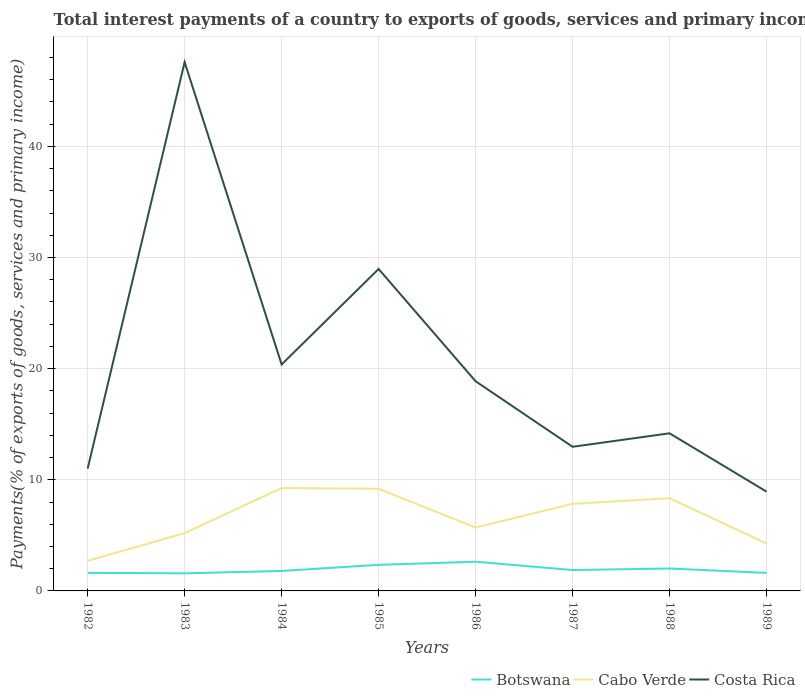How many different coloured lines are there?
Your answer should be compact. 3. Is the number of lines equal to the number of legend labels?
Your response must be concise. Yes. Across all years, what is the maximum total interest payments in Costa Rica?
Keep it short and to the point. 8.93. In which year was the total interest payments in Botswana maximum?
Offer a very short reply. 1983. What is the total total interest payments in Botswana in the graph?
Your answer should be compact. -0.04. What is the difference between the highest and the second highest total interest payments in Cabo Verde?
Offer a very short reply. 6.55. How many years are there in the graph?
Keep it short and to the point. 8. What is the difference between two consecutive major ticks on the Y-axis?
Make the answer very short. 10. Are the values on the major ticks of Y-axis written in scientific E-notation?
Provide a succinct answer. No. Where does the legend appear in the graph?
Offer a terse response. Bottom right. How many legend labels are there?
Give a very brief answer. 3. How are the legend labels stacked?
Offer a terse response. Horizontal. What is the title of the graph?
Your answer should be compact. Total interest payments of a country to exports of goods, services and primary income. Does "South Asia" appear as one of the legend labels in the graph?
Offer a terse response. No. What is the label or title of the X-axis?
Make the answer very short. Years. What is the label or title of the Y-axis?
Offer a terse response. Payments(% of exports of goods, services and primary income). What is the Payments(% of exports of goods, services and primary income) in Botswana in 1982?
Your response must be concise. 1.63. What is the Payments(% of exports of goods, services and primary income) of Cabo Verde in 1982?
Make the answer very short. 2.7. What is the Payments(% of exports of goods, services and primary income) in Costa Rica in 1982?
Ensure brevity in your answer.  11.01. What is the Payments(% of exports of goods, services and primary income) of Botswana in 1983?
Ensure brevity in your answer.  1.58. What is the Payments(% of exports of goods, services and primary income) of Cabo Verde in 1983?
Provide a short and direct response. 5.2. What is the Payments(% of exports of goods, services and primary income) of Costa Rica in 1983?
Your answer should be very brief. 47.58. What is the Payments(% of exports of goods, services and primary income) in Botswana in 1984?
Ensure brevity in your answer.  1.8. What is the Payments(% of exports of goods, services and primary income) of Cabo Verde in 1984?
Your answer should be compact. 9.26. What is the Payments(% of exports of goods, services and primary income) in Costa Rica in 1984?
Give a very brief answer. 20.37. What is the Payments(% of exports of goods, services and primary income) in Botswana in 1985?
Your answer should be compact. 2.35. What is the Payments(% of exports of goods, services and primary income) of Cabo Verde in 1985?
Keep it short and to the point. 9.19. What is the Payments(% of exports of goods, services and primary income) in Costa Rica in 1985?
Provide a short and direct response. 28.97. What is the Payments(% of exports of goods, services and primary income) in Botswana in 1986?
Offer a terse response. 2.63. What is the Payments(% of exports of goods, services and primary income) of Cabo Verde in 1986?
Make the answer very short. 5.7. What is the Payments(% of exports of goods, services and primary income) of Costa Rica in 1986?
Provide a succinct answer. 18.86. What is the Payments(% of exports of goods, services and primary income) of Botswana in 1987?
Give a very brief answer. 1.88. What is the Payments(% of exports of goods, services and primary income) of Cabo Verde in 1987?
Offer a terse response. 7.84. What is the Payments(% of exports of goods, services and primary income) of Costa Rica in 1987?
Provide a short and direct response. 12.97. What is the Payments(% of exports of goods, services and primary income) of Botswana in 1988?
Make the answer very short. 2.02. What is the Payments(% of exports of goods, services and primary income) of Cabo Verde in 1988?
Your answer should be very brief. 8.34. What is the Payments(% of exports of goods, services and primary income) of Costa Rica in 1988?
Offer a terse response. 14.18. What is the Payments(% of exports of goods, services and primary income) of Botswana in 1989?
Offer a terse response. 1.62. What is the Payments(% of exports of goods, services and primary income) in Cabo Verde in 1989?
Provide a succinct answer. 4.27. What is the Payments(% of exports of goods, services and primary income) in Costa Rica in 1989?
Ensure brevity in your answer.  8.93. Across all years, what is the maximum Payments(% of exports of goods, services and primary income) in Botswana?
Provide a succinct answer. 2.63. Across all years, what is the maximum Payments(% of exports of goods, services and primary income) of Cabo Verde?
Ensure brevity in your answer.  9.26. Across all years, what is the maximum Payments(% of exports of goods, services and primary income) of Costa Rica?
Offer a terse response. 47.58. Across all years, what is the minimum Payments(% of exports of goods, services and primary income) of Botswana?
Ensure brevity in your answer.  1.58. Across all years, what is the minimum Payments(% of exports of goods, services and primary income) of Cabo Verde?
Your answer should be compact. 2.7. Across all years, what is the minimum Payments(% of exports of goods, services and primary income) in Costa Rica?
Your answer should be compact. 8.93. What is the total Payments(% of exports of goods, services and primary income) of Botswana in the graph?
Give a very brief answer. 15.5. What is the total Payments(% of exports of goods, services and primary income) in Cabo Verde in the graph?
Offer a terse response. 52.5. What is the total Payments(% of exports of goods, services and primary income) in Costa Rica in the graph?
Offer a terse response. 162.87. What is the difference between the Payments(% of exports of goods, services and primary income) in Botswana in 1982 and that in 1983?
Ensure brevity in your answer.  0.05. What is the difference between the Payments(% of exports of goods, services and primary income) of Cabo Verde in 1982 and that in 1983?
Offer a terse response. -2.49. What is the difference between the Payments(% of exports of goods, services and primary income) in Costa Rica in 1982 and that in 1983?
Offer a terse response. -36.57. What is the difference between the Payments(% of exports of goods, services and primary income) in Botswana in 1982 and that in 1984?
Keep it short and to the point. -0.17. What is the difference between the Payments(% of exports of goods, services and primary income) of Cabo Verde in 1982 and that in 1984?
Offer a very short reply. -6.55. What is the difference between the Payments(% of exports of goods, services and primary income) in Costa Rica in 1982 and that in 1984?
Provide a short and direct response. -9.37. What is the difference between the Payments(% of exports of goods, services and primary income) of Botswana in 1982 and that in 1985?
Give a very brief answer. -0.72. What is the difference between the Payments(% of exports of goods, services and primary income) of Cabo Verde in 1982 and that in 1985?
Provide a short and direct response. -6.49. What is the difference between the Payments(% of exports of goods, services and primary income) of Costa Rica in 1982 and that in 1985?
Offer a terse response. -17.96. What is the difference between the Payments(% of exports of goods, services and primary income) in Botswana in 1982 and that in 1986?
Your answer should be very brief. -1. What is the difference between the Payments(% of exports of goods, services and primary income) of Cabo Verde in 1982 and that in 1986?
Provide a short and direct response. -3. What is the difference between the Payments(% of exports of goods, services and primary income) in Costa Rica in 1982 and that in 1986?
Ensure brevity in your answer.  -7.86. What is the difference between the Payments(% of exports of goods, services and primary income) in Botswana in 1982 and that in 1987?
Give a very brief answer. -0.25. What is the difference between the Payments(% of exports of goods, services and primary income) of Cabo Verde in 1982 and that in 1987?
Keep it short and to the point. -5.13. What is the difference between the Payments(% of exports of goods, services and primary income) in Costa Rica in 1982 and that in 1987?
Offer a very short reply. -1.96. What is the difference between the Payments(% of exports of goods, services and primary income) of Botswana in 1982 and that in 1988?
Your response must be concise. -0.39. What is the difference between the Payments(% of exports of goods, services and primary income) of Cabo Verde in 1982 and that in 1988?
Your answer should be very brief. -5.63. What is the difference between the Payments(% of exports of goods, services and primary income) in Costa Rica in 1982 and that in 1988?
Give a very brief answer. -3.18. What is the difference between the Payments(% of exports of goods, services and primary income) in Botswana in 1982 and that in 1989?
Your answer should be very brief. 0.01. What is the difference between the Payments(% of exports of goods, services and primary income) in Cabo Verde in 1982 and that in 1989?
Offer a terse response. -1.56. What is the difference between the Payments(% of exports of goods, services and primary income) in Costa Rica in 1982 and that in 1989?
Provide a short and direct response. 2.07. What is the difference between the Payments(% of exports of goods, services and primary income) of Botswana in 1983 and that in 1984?
Ensure brevity in your answer.  -0.21. What is the difference between the Payments(% of exports of goods, services and primary income) in Cabo Verde in 1983 and that in 1984?
Provide a succinct answer. -4.06. What is the difference between the Payments(% of exports of goods, services and primary income) in Costa Rica in 1983 and that in 1984?
Provide a succinct answer. 27.2. What is the difference between the Payments(% of exports of goods, services and primary income) in Botswana in 1983 and that in 1985?
Your response must be concise. -0.77. What is the difference between the Payments(% of exports of goods, services and primary income) of Cabo Verde in 1983 and that in 1985?
Keep it short and to the point. -3.99. What is the difference between the Payments(% of exports of goods, services and primary income) of Costa Rica in 1983 and that in 1985?
Offer a very short reply. 18.61. What is the difference between the Payments(% of exports of goods, services and primary income) in Botswana in 1983 and that in 1986?
Offer a very short reply. -1.04. What is the difference between the Payments(% of exports of goods, services and primary income) in Cabo Verde in 1983 and that in 1986?
Your response must be concise. -0.5. What is the difference between the Payments(% of exports of goods, services and primary income) in Costa Rica in 1983 and that in 1986?
Make the answer very short. 28.71. What is the difference between the Payments(% of exports of goods, services and primary income) of Botswana in 1983 and that in 1987?
Keep it short and to the point. -0.3. What is the difference between the Payments(% of exports of goods, services and primary income) of Cabo Verde in 1983 and that in 1987?
Provide a short and direct response. -2.64. What is the difference between the Payments(% of exports of goods, services and primary income) in Costa Rica in 1983 and that in 1987?
Offer a terse response. 34.61. What is the difference between the Payments(% of exports of goods, services and primary income) in Botswana in 1983 and that in 1988?
Provide a succinct answer. -0.44. What is the difference between the Payments(% of exports of goods, services and primary income) of Cabo Verde in 1983 and that in 1988?
Your answer should be compact. -3.14. What is the difference between the Payments(% of exports of goods, services and primary income) in Costa Rica in 1983 and that in 1988?
Provide a short and direct response. 33.4. What is the difference between the Payments(% of exports of goods, services and primary income) of Botswana in 1983 and that in 1989?
Ensure brevity in your answer.  -0.04. What is the difference between the Payments(% of exports of goods, services and primary income) of Cabo Verde in 1983 and that in 1989?
Ensure brevity in your answer.  0.93. What is the difference between the Payments(% of exports of goods, services and primary income) in Costa Rica in 1983 and that in 1989?
Your answer should be compact. 38.65. What is the difference between the Payments(% of exports of goods, services and primary income) of Botswana in 1984 and that in 1985?
Give a very brief answer. -0.55. What is the difference between the Payments(% of exports of goods, services and primary income) of Cabo Verde in 1984 and that in 1985?
Make the answer very short. 0.06. What is the difference between the Payments(% of exports of goods, services and primary income) in Costa Rica in 1984 and that in 1985?
Your response must be concise. -8.59. What is the difference between the Payments(% of exports of goods, services and primary income) of Botswana in 1984 and that in 1986?
Your response must be concise. -0.83. What is the difference between the Payments(% of exports of goods, services and primary income) of Cabo Verde in 1984 and that in 1986?
Keep it short and to the point. 3.55. What is the difference between the Payments(% of exports of goods, services and primary income) in Costa Rica in 1984 and that in 1986?
Ensure brevity in your answer.  1.51. What is the difference between the Payments(% of exports of goods, services and primary income) in Botswana in 1984 and that in 1987?
Make the answer very short. -0.08. What is the difference between the Payments(% of exports of goods, services and primary income) of Cabo Verde in 1984 and that in 1987?
Offer a very short reply. 1.42. What is the difference between the Payments(% of exports of goods, services and primary income) of Costa Rica in 1984 and that in 1987?
Offer a very short reply. 7.41. What is the difference between the Payments(% of exports of goods, services and primary income) in Botswana in 1984 and that in 1988?
Offer a very short reply. -0.22. What is the difference between the Payments(% of exports of goods, services and primary income) in Cabo Verde in 1984 and that in 1988?
Keep it short and to the point. 0.92. What is the difference between the Payments(% of exports of goods, services and primary income) of Costa Rica in 1984 and that in 1988?
Your response must be concise. 6.19. What is the difference between the Payments(% of exports of goods, services and primary income) in Botswana in 1984 and that in 1989?
Provide a short and direct response. 0.17. What is the difference between the Payments(% of exports of goods, services and primary income) in Cabo Verde in 1984 and that in 1989?
Provide a short and direct response. 4.99. What is the difference between the Payments(% of exports of goods, services and primary income) in Costa Rica in 1984 and that in 1989?
Ensure brevity in your answer.  11.44. What is the difference between the Payments(% of exports of goods, services and primary income) of Botswana in 1985 and that in 1986?
Provide a succinct answer. -0.28. What is the difference between the Payments(% of exports of goods, services and primary income) in Cabo Verde in 1985 and that in 1986?
Provide a short and direct response. 3.49. What is the difference between the Payments(% of exports of goods, services and primary income) in Costa Rica in 1985 and that in 1986?
Keep it short and to the point. 10.1. What is the difference between the Payments(% of exports of goods, services and primary income) of Botswana in 1985 and that in 1987?
Provide a short and direct response. 0.47. What is the difference between the Payments(% of exports of goods, services and primary income) in Cabo Verde in 1985 and that in 1987?
Ensure brevity in your answer.  1.35. What is the difference between the Payments(% of exports of goods, services and primary income) of Costa Rica in 1985 and that in 1987?
Your answer should be very brief. 16. What is the difference between the Payments(% of exports of goods, services and primary income) of Botswana in 1985 and that in 1988?
Provide a short and direct response. 0.33. What is the difference between the Payments(% of exports of goods, services and primary income) in Cabo Verde in 1985 and that in 1988?
Provide a short and direct response. 0.85. What is the difference between the Payments(% of exports of goods, services and primary income) in Costa Rica in 1985 and that in 1988?
Your answer should be compact. 14.78. What is the difference between the Payments(% of exports of goods, services and primary income) of Botswana in 1985 and that in 1989?
Provide a succinct answer. 0.72. What is the difference between the Payments(% of exports of goods, services and primary income) of Cabo Verde in 1985 and that in 1989?
Keep it short and to the point. 4.92. What is the difference between the Payments(% of exports of goods, services and primary income) of Costa Rica in 1985 and that in 1989?
Your answer should be very brief. 20.03. What is the difference between the Payments(% of exports of goods, services and primary income) of Botswana in 1986 and that in 1987?
Offer a very short reply. 0.75. What is the difference between the Payments(% of exports of goods, services and primary income) of Cabo Verde in 1986 and that in 1987?
Your answer should be compact. -2.14. What is the difference between the Payments(% of exports of goods, services and primary income) of Costa Rica in 1986 and that in 1987?
Offer a terse response. 5.9. What is the difference between the Payments(% of exports of goods, services and primary income) of Botswana in 1986 and that in 1988?
Provide a short and direct response. 0.61. What is the difference between the Payments(% of exports of goods, services and primary income) of Cabo Verde in 1986 and that in 1988?
Keep it short and to the point. -2.64. What is the difference between the Payments(% of exports of goods, services and primary income) in Costa Rica in 1986 and that in 1988?
Provide a short and direct response. 4.68. What is the difference between the Payments(% of exports of goods, services and primary income) in Botswana in 1986 and that in 1989?
Make the answer very short. 1. What is the difference between the Payments(% of exports of goods, services and primary income) of Cabo Verde in 1986 and that in 1989?
Ensure brevity in your answer.  1.44. What is the difference between the Payments(% of exports of goods, services and primary income) in Costa Rica in 1986 and that in 1989?
Your response must be concise. 9.93. What is the difference between the Payments(% of exports of goods, services and primary income) in Botswana in 1987 and that in 1988?
Make the answer very short. -0.14. What is the difference between the Payments(% of exports of goods, services and primary income) in Cabo Verde in 1987 and that in 1988?
Make the answer very short. -0.5. What is the difference between the Payments(% of exports of goods, services and primary income) in Costa Rica in 1987 and that in 1988?
Offer a very short reply. -1.21. What is the difference between the Payments(% of exports of goods, services and primary income) of Botswana in 1987 and that in 1989?
Keep it short and to the point. 0.26. What is the difference between the Payments(% of exports of goods, services and primary income) of Cabo Verde in 1987 and that in 1989?
Your answer should be very brief. 3.57. What is the difference between the Payments(% of exports of goods, services and primary income) of Costa Rica in 1987 and that in 1989?
Your response must be concise. 4.04. What is the difference between the Payments(% of exports of goods, services and primary income) in Botswana in 1988 and that in 1989?
Provide a short and direct response. 0.4. What is the difference between the Payments(% of exports of goods, services and primary income) of Cabo Verde in 1988 and that in 1989?
Provide a short and direct response. 4.07. What is the difference between the Payments(% of exports of goods, services and primary income) in Costa Rica in 1988 and that in 1989?
Give a very brief answer. 5.25. What is the difference between the Payments(% of exports of goods, services and primary income) of Botswana in 1982 and the Payments(% of exports of goods, services and primary income) of Cabo Verde in 1983?
Give a very brief answer. -3.57. What is the difference between the Payments(% of exports of goods, services and primary income) in Botswana in 1982 and the Payments(% of exports of goods, services and primary income) in Costa Rica in 1983?
Offer a very short reply. -45.95. What is the difference between the Payments(% of exports of goods, services and primary income) in Cabo Verde in 1982 and the Payments(% of exports of goods, services and primary income) in Costa Rica in 1983?
Give a very brief answer. -44.87. What is the difference between the Payments(% of exports of goods, services and primary income) of Botswana in 1982 and the Payments(% of exports of goods, services and primary income) of Cabo Verde in 1984?
Your response must be concise. -7.63. What is the difference between the Payments(% of exports of goods, services and primary income) of Botswana in 1982 and the Payments(% of exports of goods, services and primary income) of Costa Rica in 1984?
Keep it short and to the point. -18.75. What is the difference between the Payments(% of exports of goods, services and primary income) in Cabo Verde in 1982 and the Payments(% of exports of goods, services and primary income) in Costa Rica in 1984?
Provide a succinct answer. -17.67. What is the difference between the Payments(% of exports of goods, services and primary income) in Botswana in 1982 and the Payments(% of exports of goods, services and primary income) in Cabo Verde in 1985?
Give a very brief answer. -7.56. What is the difference between the Payments(% of exports of goods, services and primary income) in Botswana in 1982 and the Payments(% of exports of goods, services and primary income) in Costa Rica in 1985?
Provide a succinct answer. -27.34. What is the difference between the Payments(% of exports of goods, services and primary income) in Cabo Verde in 1982 and the Payments(% of exports of goods, services and primary income) in Costa Rica in 1985?
Your answer should be very brief. -26.26. What is the difference between the Payments(% of exports of goods, services and primary income) of Botswana in 1982 and the Payments(% of exports of goods, services and primary income) of Cabo Verde in 1986?
Offer a terse response. -4.07. What is the difference between the Payments(% of exports of goods, services and primary income) in Botswana in 1982 and the Payments(% of exports of goods, services and primary income) in Costa Rica in 1986?
Keep it short and to the point. -17.24. What is the difference between the Payments(% of exports of goods, services and primary income) in Cabo Verde in 1982 and the Payments(% of exports of goods, services and primary income) in Costa Rica in 1986?
Your response must be concise. -16.16. What is the difference between the Payments(% of exports of goods, services and primary income) of Botswana in 1982 and the Payments(% of exports of goods, services and primary income) of Cabo Verde in 1987?
Your answer should be very brief. -6.21. What is the difference between the Payments(% of exports of goods, services and primary income) in Botswana in 1982 and the Payments(% of exports of goods, services and primary income) in Costa Rica in 1987?
Give a very brief answer. -11.34. What is the difference between the Payments(% of exports of goods, services and primary income) in Cabo Verde in 1982 and the Payments(% of exports of goods, services and primary income) in Costa Rica in 1987?
Your response must be concise. -10.26. What is the difference between the Payments(% of exports of goods, services and primary income) of Botswana in 1982 and the Payments(% of exports of goods, services and primary income) of Cabo Verde in 1988?
Provide a short and direct response. -6.71. What is the difference between the Payments(% of exports of goods, services and primary income) of Botswana in 1982 and the Payments(% of exports of goods, services and primary income) of Costa Rica in 1988?
Your answer should be compact. -12.55. What is the difference between the Payments(% of exports of goods, services and primary income) of Cabo Verde in 1982 and the Payments(% of exports of goods, services and primary income) of Costa Rica in 1988?
Provide a short and direct response. -11.48. What is the difference between the Payments(% of exports of goods, services and primary income) in Botswana in 1982 and the Payments(% of exports of goods, services and primary income) in Cabo Verde in 1989?
Ensure brevity in your answer.  -2.64. What is the difference between the Payments(% of exports of goods, services and primary income) of Botswana in 1982 and the Payments(% of exports of goods, services and primary income) of Costa Rica in 1989?
Offer a very short reply. -7.3. What is the difference between the Payments(% of exports of goods, services and primary income) in Cabo Verde in 1982 and the Payments(% of exports of goods, services and primary income) in Costa Rica in 1989?
Offer a very short reply. -6.23. What is the difference between the Payments(% of exports of goods, services and primary income) of Botswana in 1983 and the Payments(% of exports of goods, services and primary income) of Cabo Verde in 1984?
Provide a short and direct response. -7.67. What is the difference between the Payments(% of exports of goods, services and primary income) of Botswana in 1983 and the Payments(% of exports of goods, services and primary income) of Costa Rica in 1984?
Provide a short and direct response. -18.79. What is the difference between the Payments(% of exports of goods, services and primary income) in Cabo Verde in 1983 and the Payments(% of exports of goods, services and primary income) in Costa Rica in 1984?
Your answer should be compact. -15.17. What is the difference between the Payments(% of exports of goods, services and primary income) in Botswana in 1983 and the Payments(% of exports of goods, services and primary income) in Cabo Verde in 1985?
Keep it short and to the point. -7.61. What is the difference between the Payments(% of exports of goods, services and primary income) in Botswana in 1983 and the Payments(% of exports of goods, services and primary income) in Costa Rica in 1985?
Give a very brief answer. -27.38. What is the difference between the Payments(% of exports of goods, services and primary income) of Cabo Verde in 1983 and the Payments(% of exports of goods, services and primary income) of Costa Rica in 1985?
Ensure brevity in your answer.  -23.77. What is the difference between the Payments(% of exports of goods, services and primary income) of Botswana in 1983 and the Payments(% of exports of goods, services and primary income) of Cabo Verde in 1986?
Your response must be concise. -4.12. What is the difference between the Payments(% of exports of goods, services and primary income) in Botswana in 1983 and the Payments(% of exports of goods, services and primary income) in Costa Rica in 1986?
Offer a very short reply. -17.28. What is the difference between the Payments(% of exports of goods, services and primary income) in Cabo Verde in 1983 and the Payments(% of exports of goods, services and primary income) in Costa Rica in 1986?
Your answer should be compact. -13.67. What is the difference between the Payments(% of exports of goods, services and primary income) in Botswana in 1983 and the Payments(% of exports of goods, services and primary income) in Cabo Verde in 1987?
Your response must be concise. -6.26. What is the difference between the Payments(% of exports of goods, services and primary income) of Botswana in 1983 and the Payments(% of exports of goods, services and primary income) of Costa Rica in 1987?
Offer a terse response. -11.39. What is the difference between the Payments(% of exports of goods, services and primary income) of Cabo Verde in 1983 and the Payments(% of exports of goods, services and primary income) of Costa Rica in 1987?
Your response must be concise. -7.77. What is the difference between the Payments(% of exports of goods, services and primary income) of Botswana in 1983 and the Payments(% of exports of goods, services and primary income) of Cabo Verde in 1988?
Offer a very short reply. -6.76. What is the difference between the Payments(% of exports of goods, services and primary income) in Botswana in 1983 and the Payments(% of exports of goods, services and primary income) in Costa Rica in 1988?
Make the answer very short. -12.6. What is the difference between the Payments(% of exports of goods, services and primary income) of Cabo Verde in 1983 and the Payments(% of exports of goods, services and primary income) of Costa Rica in 1988?
Provide a short and direct response. -8.98. What is the difference between the Payments(% of exports of goods, services and primary income) of Botswana in 1983 and the Payments(% of exports of goods, services and primary income) of Cabo Verde in 1989?
Offer a terse response. -2.69. What is the difference between the Payments(% of exports of goods, services and primary income) in Botswana in 1983 and the Payments(% of exports of goods, services and primary income) in Costa Rica in 1989?
Your answer should be compact. -7.35. What is the difference between the Payments(% of exports of goods, services and primary income) of Cabo Verde in 1983 and the Payments(% of exports of goods, services and primary income) of Costa Rica in 1989?
Make the answer very short. -3.73. What is the difference between the Payments(% of exports of goods, services and primary income) of Botswana in 1984 and the Payments(% of exports of goods, services and primary income) of Cabo Verde in 1985?
Make the answer very short. -7.39. What is the difference between the Payments(% of exports of goods, services and primary income) in Botswana in 1984 and the Payments(% of exports of goods, services and primary income) in Costa Rica in 1985?
Keep it short and to the point. -27.17. What is the difference between the Payments(% of exports of goods, services and primary income) in Cabo Verde in 1984 and the Payments(% of exports of goods, services and primary income) in Costa Rica in 1985?
Ensure brevity in your answer.  -19.71. What is the difference between the Payments(% of exports of goods, services and primary income) of Botswana in 1984 and the Payments(% of exports of goods, services and primary income) of Cabo Verde in 1986?
Give a very brief answer. -3.91. What is the difference between the Payments(% of exports of goods, services and primary income) in Botswana in 1984 and the Payments(% of exports of goods, services and primary income) in Costa Rica in 1986?
Provide a succinct answer. -17.07. What is the difference between the Payments(% of exports of goods, services and primary income) in Cabo Verde in 1984 and the Payments(% of exports of goods, services and primary income) in Costa Rica in 1986?
Your answer should be very brief. -9.61. What is the difference between the Payments(% of exports of goods, services and primary income) in Botswana in 1984 and the Payments(% of exports of goods, services and primary income) in Cabo Verde in 1987?
Provide a short and direct response. -6.04. What is the difference between the Payments(% of exports of goods, services and primary income) of Botswana in 1984 and the Payments(% of exports of goods, services and primary income) of Costa Rica in 1987?
Ensure brevity in your answer.  -11.17. What is the difference between the Payments(% of exports of goods, services and primary income) of Cabo Verde in 1984 and the Payments(% of exports of goods, services and primary income) of Costa Rica in 1987?
Give a very brief answer. -3.71. What is the difference between the Payments(% of exports of goods, services and primary income) in Botswana in 1984 and the Payments(% of exports of goods, services and primary income) in Cabo Verde in 1988?
Give a very brief answer. -6.54. What is the difference between the Payments(% of exports of goods, services and primary income) in Botswana in 1984 and the Payments(% of exports of goods, services and primary income) in Costa Rica in 1988?
Your response must be concise. -12.38. What is the difference between the Payments(% of exports of goods, services and primary income) of Cabo Verde in 1984 and the Payments(% of exports of goods, services and primary income) of Costa Rica in 1988?
Ensure brevity in your answer.  -4.93. What is the difference between the Payments(% of exports of goods, services and primary income) of Botswana in 1984 and the Payments(% of exports of goods, services and primary income) of Cabo Verde in 1989?
Keep it short and to the point. -2.47. What is the difference between the Payments(% of exports of goods, services and primary income) of Botswana in 1984 and the Payments(% of exports of goods, services and primary income) of Costa Rica in 1989?
Provide a short and direct response. -7.13. What is the difference between the Payments(% of exports of goods, services and primary income) in Cabo Verde in 1984 and the Payments(% of exports of goods, services and primary income) in Costa Rica in 1989?
Your answer should be compact. 0.32. What is the difference between the Payments(% of exports of goods, services and primary income) of Botswana in 1985 and the Payments(% of exports of goods, services and primary income) of Cabo Verde in 1986?
Provide a succinct answer. -3.36. What is the difference between the Payments(% of exports of goods, services and primary income) in Botswana in 1985 and the Payments(% of exports of goods, services and primary income) in Costa Rica in 1986?
Keep it short and to the point. -16.52. What is the difference between the Payments(% of exports of goods, services and primary income) in Cabo Verde in 1985 and the Payments(% of exports of goods, services and primary income) in Costa Rica in 1986?
Your answer should be compact. -9.67. What is the difference between the Payments(% of exports of goods, services and primary income) in Botswana in 1985 and the Payments(% of exports of goods, services and primary income) in Cabo Verde in 1987?
Provide a succinct answer. -5.49. What is the difference between the Payments(% of exports of goods, services and primary income) in Botswana in 1985 and the Payments(% of exports of goods, services and primary income) in Costa Rica in 1987?
Give a very brief answer. -10.62. What is the difference between the Payments(% of exports of goods, services and primary income) of Cabo Verde in 1985 and the Payments(% of exports of goods, services and primary income) of Costa Rica in 1987?
Offer a very short reply. -3.78. What is the difference between the Payments(% of exports of goods, services and primary income) of Botswana in 1985 and the Payments(% of exports of goods, services and primary income) of Cabo Verde in 1988?
Offer a terse response. -5.99. What is the difference between the Payments(% of exports of goods, services and primary income) in Botswana in 1985 and the Payments(% of exports of goods, services and primary income) in Costa Rica in 1988?
Ensure brevity in your answer.  -11.83. What is the difference between the Payments(% of exports of goods, services and primary income) of Cabo Verde in 1985 and the Payments(% of exports of goods, services and primary income) of Costa Rica in 1988?
Make the answer very short. -4.99. What is the difference between the Payments(% of exports of goods, services and primary income) of Botswana in 1985 and the Payments(% of exports of goods, services and primary income) of Cabo Verde in 1989?
Offer a terse response. -1.92. What is the difference between the Payments(% of exports of goods, services and primary income) in Botswana in 1985 and the Payments(% of exports of goods, services and primary income) in Costa Rica in 1989?
Your answer should be very brief. -6.58. What is the difference between the Payments(% of exports of goods, services and primary income) in Cabo Verde in 1985 and the Payments(% of exports of goods, services and primary income) in Costa Rica in 1989?
Your answer should be compact. 0.26. What is the difference between the Payments(% of exports of goods, services and primary income) of Botswana in 1986 and the Payments(% of exports of goods, services and primary income) of Cabo Verde in 1987?
Make the answer very short. -5.21. What is the difference between the Payments(% of exports of goods, services and primary income) of Botswana in 1986 and the Payments(% of exports of goods, services and primary income) of Costa Rica in 1987?
Your response must be concise. -10.34. What is the difference between the Payments(% of exports of goods, services and primary income) of Cabo Verde in 1986 and the Payments(% of exports of goods, services and primary income) of Costa Rica in 1987?
Offer a very short reply. -7.27. What is the difference between the Payments(% of exports of goods, services and primary income) of Botswana in 1986 and the Payments(% of exports of goods, services and primary income) of Cabo Verde in 1988?
Provide a succinct answer. -5.71. What is the difference between the Payments(% of exports of goods, services and primary income) in Botswana in 1986 and the Payments(% of exports of goods, services and primary income) in Costa Rica in 1988?
Provide a succinct answer. -11.56. What is the difference between the Payments(% of exports of goods, services and primary income) in Cabo Verde in 1986 and the Payments(% of exports of goods, services and primary income) in Costa Rica in 1988?
Provide a short and direct response. -8.48. What is the difference between the Payments(% of exports of goods, services and primary income) of Botswana in 1986 and the Payments(% of exports of goods, services and primary income) of Cabo Verde in 1989?
Provide a short and direct response. -1.64. What is the difference between the Payments(% of exports of goods, services and primary income) in Botswana in 1986 and the Payments(% of exports of goods, services and primary income) in Costa Rica in 1989?
Keep it short and to the point. -6.31. What is the difference between the Payments(% of exports of goods, services and primary income) of Cabo Verde in 1986 and the Payments(% of exports of goods, services and primary income) of Costa Rica in 1989?
Give a very brief answer. -3.23. What is the difference between the Payments(% of exports of goods, services and primary income) in Botswana in 1987 and the Payments(% of exports of goods, services and primary income) in Cabo Verde in 1988?
Make the answer very short. -6.46. What is the difference between the Payments(% of exports of goods, services and primary income) in Botswana in 1987 and the Payments(% of exports of goods, services and primary income) in Costa Rica in 1988?
Your answer should be compact. -12.3. What is the difference between the Payments(% of exports of goods, services and primary income) in Cabo Verde in 1987 and the Payments(% of exports of goods, services and primary income) in Costa Rica in 1988?
Your response must be concise. -6.34. What is the difference between the Payments(% of exports of goods, services and primary income) of Botswana in 1987 and the Payments(% of exports of goods, services and primary income) of Cabo Verde in 1989?
Keep it short and to the point. -2.39. What is the difference between the Payments(% of exports of goods, services and primary income) of Botswana in 1987 and the Payments(% of exports of goods, services and primary income) of Costa Rica in 1989?
Provide a short and direct response. -7.05. What is the difference between the Payments(% of exports of goods, services and primary income) of Cabo Verde in 1987 and the Payments(% of exports of goods, services and primary income) of Costa Rica in 1989?
Offer a terse response. -1.09. What is the difference between the Payments(% of exports of goods, services and primary income) in Botswana in 1988 and the Payments(% of exports of goods, services and primary income) in Cabo Verde in 1989?
Provide a short and direct response. -2.25. What is the difference between the Payments(% of exports of goods, services and primary income) in Botswana in 1988 and the Payments(% of exports of goods, services and primary income) in Costa Rica in 1989?
Make the answer very short. -6.91. What is the difference between the Payments(% of exports of goods, services and primary income) in Cabo Verde in 1988 and the Payments(% of exports of goods, services and primary income) in Costa Rica in 1989?
Give a very brief answer. -0.59. What is the average Payments(% of exports of goods, services and primary income) in Botswana per year?
Offer a very short reply. 1.94. What is the average Payments(% of exports of goods, services and primary income) in Cabo Verde per year?
Give a very brief answer. 6.56. What is the average Payments(% of exports of goods, services and primary income) of Costa Rica per year?
Make the answer very short. 20.36. In the year 1982, what is the difference between the Payments(% of exports of goods, services and primary income) in Botswana and Payments(% of exports of goods, services and primary income) in Cabo Verde?
Offer a terse response. -1.08. In the year 1982, what is the difference between the Payments(% of exports of goods, services and primary income) in Botswana and Payments(% of exports of goods, services and primary income) in Costa Rica?
Provide a succinct answer. -9.38. In the year 1982, what is the difference between the Payments(% of exports of goods, services and primary income) in Cabo Verde and Payments(% of exports of goods, services and primary income) in Costa Rica?
Your answer should be compact. -8.3. In the year 1983, what is the difference between the Payments(% of exports of goods, services and primary income) of Botswana and Payments(% of exports of goods, services and primary income) of Cabo Verde?
Give a very brief answer. -3.62. In the year 1983, what is the difference between the Payments(% of exports of goods, services and primary income) in Botswana and Payments(% of exports of goods, services and primary income) in Costa Rica?
Your answer should be very brief. -45.99. In the year 1983, what is the difference between the Payments(% of exports of goods, services and primary income) in Cabo Verde and Payments(% of exports of goods, services and primary income) in Costa Rica?
Make the answer very short. -42.38. In the year 1984, what is the difference between the Payments(% of exports of goods, services and primary income) of Botswana and Payments(% of exports of goods, services and primary income) of Cabo Verde?
Provide a short and direct response. -7.46. In the year 1984, what is the difference between the Payments(% of exports of goods, services and primary income) in Botswana and Payments(% of exports of goods, services and primary income) in Costa Rica?
Offer a terse response. -18.58. In the year 1984, what is the difference between the Payments(% of exports of goods, services and primary income) of Cabo Verde and Payments(% of exports of goods, services and primary income) of Costa Rica?
Keep it short and to the point. -11.12. In the year 1985, what is the difference between the Payments(% of exports of goods, services and primary income) in Botswana and Payments(% of exports of goods, services and primary income) in Cabo Verde?
Offer a very short reply. -6.84. In the year 1985, what is the difference between the Payments(% of exports of goods, services and primary income) of Botswana and Payments(% of exports of goods, services and primary income) of Costa Rica?
Keep it short and to the point. -26.62. In the year 1985, what is the difference between the Payments(% of exports of goods, services and primary income) of Cabo Verde and Payments(% of exports of goods, services and primary income) of Costa Rica?
Make the answer very short. -19.77. In the year 1986, what is the difference between the Payments(% of exports of goods, services and primary income) of Botswana and Payments(% of exports of goods, services and primary income) of Cabo Verde?
Ensure brevity in your answer.  -3.08. In the year 1986, what is the difference between the Payments(% of exports of goods, services and primary income) of Botswana and Payments(% of exports of goods, services and primary income) of Costa Rica?
Offer a very short reply. -16.24. In the year 1986, what is the difference between the Payments(% of exports of goods, services and primary income) of Cabo Verde and Payments(% of exports of goods, services and primary income) of Costa Rica?
Provide a short and direct response. -13.16. In the year 1987, what is the difference between the Payments(% of exports of goods, services and primary income) of Botswana and Payments(% of exports of goods, services and primary income) of Cabo Verde?
Give a very brief answer. -5.96. In the year 1987, what is the difference between the Payments(% of exports of goods, services and primary income) in Botswana and Payments(% of exports of goods, services and primary income) in Costa Rica?
Offer a terse response. -11.09. In the year 1987, what is the difference between the Payments(% of exports of goods, services and primary income) of Cabo Verde and Payments(% of exports of goods, services and primary income) of Costa Rica?
Your answer should be compact. -5.13. In the year 1988, what is the difference between the Payments(% of exports of goods, services and primary income) of Botswana and Payments(% of exports of goods, services and primary income) of Cabo Verde?
Make the answer very short. -6.32. In the year 1988, what is the difference between the Payments(% of exports of goods, services and primary income) of Botswana and Payments(% of exports of goods, services and primary income) of Costa Rica?
Your answer should be very brief. -12.16. In the year 1988, what is the difference between the Payments(% of exports of goods, services and primary income) in Cabo Verde and Payments(% of exports of goods, services and primary income) in Costa Rica?
Ensure brevity in your answer.  -5.84. In the year 1989, what is the difference between the Payments(% of exports of goods, services and primary income) in Botswana and Payments(% of exports of goods, services and primary income) in Cabo Verde?
Provide a succinct answer. -2.65. In the year 1989, what is the difference between the Payments(% of exports of goods, services and primary income) in Botswana and Payments(% of exports of goods, services and primary income) in Costa Rica?
Make the answer very short. -7.31. In the year 1989, what is the difference between the Payments(% of exports of goods, services and primary income) of Cabo Verde and Payments(% of exports of goods, services and primary income) of Costa Rica?
Your answer should be compact. -4.66. What is the ratio of the Payments(% of exports of goods, services and primary income) of Botswana in 1982 to that in 1983?
Make the answer very short. 1.03. What is the ratio of the Payments(% of exports of goods, services and primary income) in Cabo Verde in 1982 to that in 1983?
Your response must be concise. 0.52. What is the ratio of the Payments(% of exports of goods, services and primary income) in Costa Rica in 1982 to that in 1983?
Provide a short and direct response. 0.23. What is the ratio of the Payments(% of exports of goods, services and primary income) of Botswana in 1982 to that in 1984?
Your response must be concise. 0.91. What is the ratio of the Payments(% of exports of goods, services and primary income) of Cabo Verde in 1982 to that in 1984?
Provide a succinct answer. 0.29. What is the ratio of the Payments(% of exports of goods, services and primary income) in Costa Rica in 1982 to that in 1984?
Give a very brief answer. 0.54. What is the ratio of the Payments(% of exports of goods, services and primary income) of Botswana in 1982 to that in 1985?
Your response must be concise. 0.69. What is the ratio of the Payments(% of exports of goods, services and primary income) of Cabo Verde in 1982 to that in 1985?
Offer a very short reply. 0.29. What is the ratio of the Payments(% of exports of goods, services and primary income) in Costa Rica in 1982 to that in 1985?
Provide a short and direct response. 0.38. What is the ratio of the Payments(% of exports of goods, services and primary income) of Botswana in 1982 to that in 1986?
Your answer should be compact. 0.62. What is the ratio of the Payments(% of exports of goods, services and primary income) in Cabo Verde in 1982 to that in 1986?
Make the answer very short. 0.47. What is the ratio of the Payments(% of exports of goods, services and primary income) in Costa Rica in 1982 to that in 1986?
Offer a very short reply. 0.58. What is the ratio of the Payments(% of exports of goods, services and primary income) in Botswana in 1982 to that in 1987?
Your answer should be compact. 0.87. What is the ratio of the Payments(% of exports of goods, services and primary income) in Cabo Verde in 1982 to that in 1987?
Offer a terse response. 0.35. What is the ratio of the Payments(% of exports of goods, services and primary income) in Costa Rica in 1982 to that in 1987?
Keep it short and to the point. 0.85. What is the ratio of the Payments(% of exports of goods, services and primary income) in Botswana in 1982 to that in 1988?
Provide a short and direct response. 0.81. What is the ratio of the Payments(% of exports of goods, services and primary income) in Cabo Verde in 1982 to that in 1988?
Provide a short and direct response. 0.32. What is the ratio of the Payments(% of exports of goods, services and primary income) of Costa Rica in 1982 to that in 1988?
Provide a short and direct response. 0.78. What is the ratio of the Payments(% of exports of goods, services and primary income) in Botswana in 1982 to that in 1989?
Make the answer very short. 1. What is the ratio of the Payments(% of exports of goods, services and primary income) of Cabo Verde in 1982 to that in 1989?
Keep it short and to the point. 0.63. What is the ratio of the Payments(% of exports of goods, services and primary income) of Costa Rica in 1982 to that in 1989?
Your response must be concise. 1.23. What is the ratio of the Payments(% of exports of goods, services and primary income) in Botswana in 1983 to that in 1984?
Keep it short and to the point. 0.88. What is the ratio of the Payments(% of exports of goods, services and primary income) of Cabo Verde in 1983 to that in 1984?
Offer a very short reply. 0.56. What is the ratio of the Payments(% of exports of goods, services and primary income) of Costa Rica in 1983 to that in 1984?
Offer a very short reply. 2.34. What is the ratio of the Payments(% of exports of goods, services and primary income) in Botswana in 1983 to that in 1985?
Your answer should be compact. 0.67. What is the ratio of the Payments(% of exports of goods, services and primary income) of Cabo Verde in 1983 to that in 1985?
Your answer should be compact. 0.57. What is the ratio of the Payments(% of exports of goods, services and primary income) of Costa Rica in 1983 to that in 1985?
Your answer should be very brief. 1.64. What is the ratio of the Payments(% of exports of goods, services and primary income) of Botswana in 1983 to that in 1986?
Provide a succinct answer. 0.6. What is the ratio of the Payments(% of exports of goods, services and primary income) of Cabo Verde in 1983 to that in 1986?
Make the answer very short. 0.91. What is the ratio of the Payments(% of exports of goods, services and primary income) in Costa Rica in 1983 to that in 1986?
Your answer should be very brief. 2.52. What is the ratio of the Payments(% of exports of goods, services and primary income) of Botswana in 1983 to that in 1987?
Make the answer very short. 0.84. What is the ratio of the Payments(% of exports of goods, services and primary income) in Cabo Verde in 1983 to that in 1987?
Give a very brief answer. 0.66. What is the ratio of the Payments(% of exports of goods, services and primary income) of Costa Rica in 1983 to that in 1987?
Your answer should be compact. 3.67. What is the ratio of the Payments(% of exports of goods, services and primary income) of Botswana in 1983 to that in 1988?
Make the answer very short. 0.78. What is the ratio of the Payments(% of exports of goods, services and primary income) of Cabo Verde in 1983 to that in 1988?
Offer a very short reply. 0.62. What is the ratio of the Payments(% of exports of goods, services and primary income) in Costa Rica in 1983 to that in 1988?
Offer a terse response. 3.35. What is the ratio of the Payments(% of exports of goods, services and primary income) of Botswana in 1983 to that in 1989?
Make the answer very short. 0.98. What is the ratio of the Payments(% of exports of goods, services and primary income) in Cabo Verde in 1983 to that in 1989?
Your answer should be compact. 1.22. What is the ratio of the Payments(% of exports of goods, services and primary income) of Costa Rica in 1983 to that in 1989?
Offer a terse response. 5.33. What is the ratio of the Payments(% of exports of goods, services and primary income) of Botswana in 1984 to that in 1985?
Your response must be concise. 0.77. What is the ratio of the Payments(% of exports of goods, services and primary income) in Cabo Verde in 1984 to that in 1985?
Your answer should be compact. 1.01. What is the ratio of the Payments(% of exports of goods, services and primary income) in Costa Rica in 1984 to that in 1985?
Offer a terse response. 0.7. What is the ratio of the Payments(% of exports of goods, services and primary income) in Botswana in 1984 to that in 1986?
Give a very brief answer. 0.68. What is the ratio of the Payments(% of exports of goods, services and primary income) of Cabo Verde in 1984 to that in 1986?
Make the answer very short. 1.62. What is the ratio of the Payments(% of exports of goods, services and primary income) in Costa Rica in 1984 to that in 1986?
Your answer should be compact. 1.08. What is the ratio of the Payments(% of exports of goods, services and primary income) in Botswana in 1984 to that in 1987?
Make the answer very short. 0.96. What is the ratio of the Payments(% of exports of goods, services and primary income) of Cabo Verde in 1984 to that in 1987?
Your answer should be compact. 1.18. What is the ratio of the Payments(% of exports of goods, services and primary income) of Costa Rica in 1984 to that in 1987?
Keep it short and to the point. 1.57. What is the ratio of the Payments(% of exports of goods, services and primary income) of Botswana in 1984 to that in 1988?
Offer a very short reply. 0.89. What is the ratio of the Payments(% of exports of goods, services and primary income) of Cabo Verde in 1984 to that in 1988?
Make the answer very short. 1.11. What is the ratio of the Payments(% of exports of goods, services and primary income) of Costa Rica in 1984 to that in 1988?
Keep it short and to the point. 1.44. What is the ratio of the Payments(% of exports of goods, services and primary income) of Botswana in 1984 to that in 1989?
Keep it short and to the point. 1.11. What is the ratio of the Payments(% of exports of goods, services and primary income) in Cabo Verde in 1984 to that in 1989?
Your response must be concise. 2.17. What is the ratio of the Payments(% of exports of goods, services and primary income) of Costa Rica in 1984 to that in 1989?
Make the answer very short. 2.28. What is the ratio of the Payments(% of exports of goods, services and primary income) in Botswana in 1985 to that in 1986?
Provide a succinct answer. 0.89. What is the ratio of the Payments(% of exports of goods, services and primary income) of Cabo Verde in 1985 to that in 1986?
Give a very brief answer. 1.61. What is the ratio of the Payments(% of exports of goods, services and primary income) in Costa Rica in 1985 to that in 1986?
Make the answer very short. 1.54. What is the ratio of the Payments(% of exports of goods, services and primary income) of Botswana in 1985 to that in 1987?
Your response must be concise. 1.25. What is the ratio of the Payments(% of exports of goods, services and primary income) in Cabo Verde in 1985 to that in 1987?
Offer a terse response. 1.17. What is the ratio of the Payments(% of exports of goods, services and primary income) of Costa Rica in 1985 to that in 1987?
Offer a very short reply. 2.23. What is the ratio of the Payments(% of exports of goods, services and primary income) in Botswana in 1985 to that in 1988?
Provide a short and direct response. 1.16. What is the ratio of the Payments(% of exports of goods, services and primary income) in Cabo Verde in 1985 to that in 1988?
Your answer should be compact. 1.1. What is the ratio of the Payments(% of exports of goods, services and primary income) in Costa Rica in 1985 to that in 1988?
Provide a short and direct response. 2.04. What is the ratio of the Payments(% of exports of goods, services and primary income) of Botswana in 1985 to that in 1989?
Offer a terse response. 1.45. What is the ratio of the Payments(% of exports of goods, services and primary income) of Cabo Verde in 1985 to that in 1989?
Your answer should be compact. 2.15. What is the ratio of the Payments(% of exports of goods, services and primary income) in Costa Rica in 1985 to that in 1989?
Give a very brief answer. 3.24. What is the ratio of the Payments(% of exports of goods, services and primary income) of Botswana in 1986 to that in 1987?
Provide a short and direct response. 1.4. What is the ratio of the Payments(% of exports of goods, services and primary income) in Cabo Verde in 1986 to that in 1987?
Give a very brief answer. 0.73. What is the ratio of the Payments(% of exports of goods, services and primary income) of Costa Rica in 1986 to that in 1987?
Keep it short and to the point. 1.45. What is the ratio of the Payments(% of exports of goods, services and primary income) in Botswana in 1986 to that in 1988?
Keep it short and to the point. 1.3. What is the ratio of the Payments(% of exports of goods, services and primary income) in Cabo Verde in 1986 to that in 1988?
Keep it short and to the point. 0.68. What is the ratio of the Payments(% of exports of goods, services and primary income) in Costa Rica in 1986 to that in 1988?
Provide a short and direct response. 1.33. What is the ratio of the Payments(% of exports of goods, services and primary income) of Botswana in 1986 to that in 1989?
Offer a very short reply. 1.62. What is the ratio of the Payments(% of exports of goods, services and primary income) in Cabo Verde in 1986 to that in 1989?
Provide a succinct answer. 1.34. What is the ratio of the Payments(% of exports of goods, services and primary income) of Costa Rica in 1986 to that in 1989?
Your answer should be very brief. 2.11. What is the ratio of the Payments(% of exports of goods, services and primary income) in Botswana in 1987 to that in 1988?
Provide a short and direct response. 0.93. What is the ratio of the Payments(% of exports of goods, services and primary income) in Costa Rica in 1987 to that in 1988?
Keep it short and to the point. 0.91. What is the ratio of the Payments(% of exports of goods, services and primary income) in Botswana in 1987 to that in 1989?
Give a very brief answer. 1.16. What is the ratio of the Payments(% of exports of goods, services and primary income) of Cabo Verde in 1987 to that in 1989?
Ensure brevity in your answer.  1.84. What is the ratio of the Payments(% of exports of goods, services and primary income) in Costa Rica in 1987 to that in 1989?
Make the answer very short. 1.45. What is the ratio of the Payments(% of exports of goods, services and primary income) of Botswana in 1988 to that in 1989?
Give a very brief answer. 1.24. What is the ratio of the Payments(% of exports of goods, services and primary income) in Cabo Verde in 1988 to that in 1989?
Provide a succinct answer. 1.95. What is the ratio of the Payments(% of exports of goods, services and primary income) in Costa Rica in 1988 to that in 1989?
Give a very brief answer. 1.59. What is the difference between the highest and the second highest Payments(% of exports of goods, services and primary income) in Botswana?
Your response must be concise. 0.28. What is the difference between the highest and the second highest Payments(% of exports of goods, services and primary income) in Cabo Verde?
Provide a succinct answer. 0.06. What is the difference between the highest and the second highest Payments(% of exports of goods, services and primary income) in Costa Rica?
Provide a succinct answer. 18.61. What is the difference between the highest and the lowest Payments(% of exports of goods, services and primary income) in Botswana?
Provide a succinct answer. 1.04. What is the difference between the highest and the lowest Payments(% of exports of goods, services and primary income) in Cabo Verde?
Provide a succinct answer. 6.55. What is the difference between the highest and the lowest Payments(% of exports of goods, services and primary income) of Costa Rica?
Provide a succinct answer. 38.65. 